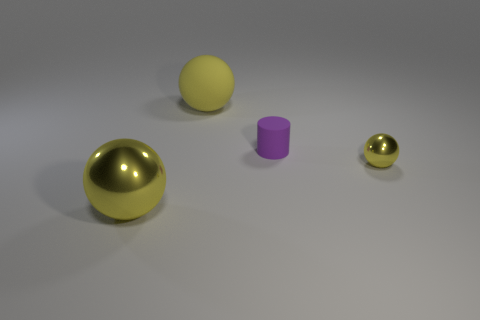How many tiny things are either yellow metallic cubes or yellow things?
Provide a succinct answer. 1. How many large yellow metal balls are there?
Your response must be concise. 1. There is a sphere behind the tiny yellow object; what material is it?
Provide a succinct answer. Rubber. There is a small metallic sphere; are there any rubber spheres behind it?
Offer a very short reply. Yes. How many other tiny cylinders are made of the same material as the cylinder?
Offer a terse response. 0. What is the size of the yellow metal sphere left of the metal ball that is to the right of the big rubber ball?
Keep it short and to the point. Large. What is the color of the sphere that is on the left side of the tiny purple thing and in front of the rubber cylinder?
Your response must be concise. Yellow. Do the large yellow rubber object and the purple matte thing have the same shape?
Your response must be concise. No. What is the size of the metal object that is the same color as the large shiny ball?
Make the answer very short. Small. What shape is the large yellow matte object right of the thing in front of the small yellow metal object?
Keep it short and to the point. Sphere. 